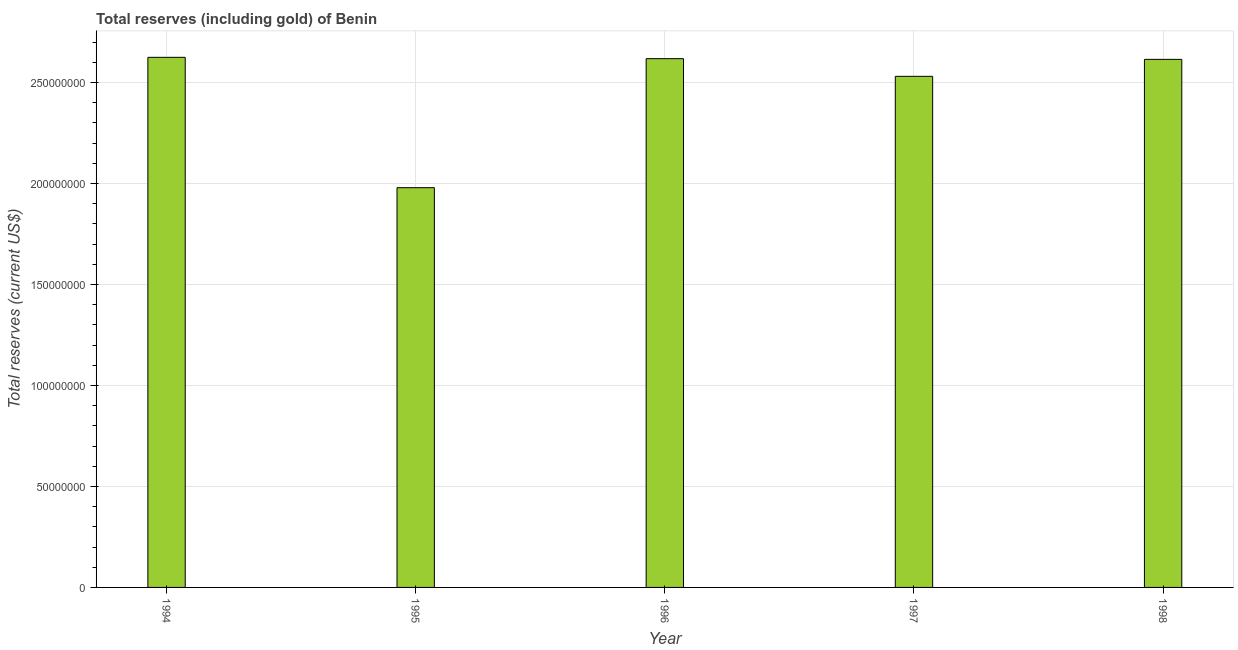What is the title of the graph?
Ensure brevity in your answer.  Total reserves (including gold) of Benin. What is the label or title of the Y-axis?
Offer a terse response. Total reserves (current US$). What is the total reserves (including gold) in 1996?
Make the answer very short. 2.62e+08. Across all years, what is the maximum total reserves (including gold)?
Offer a terse response. 2.62e+08. Across all years, what is the minimum total reserves (including gold)?
Ensure brevity in your answer.  1.98e+08. In which year was the total reserves (including gold) minimum?
Provide a short and direct response. 1995. What is the sum of the total reserves (including gold)?
Keep it short and to the point. 1.24e+09. What is the difference between the total reserves (including gold) in 1994 and 1996?
Make the answer very short. 6.64e+05. What is the average total reserves (including gold) per year?
Your answer should be compact. 2.47e+08. What is the median total reserves (including gold)?
Make the answer very short. 2.61e+08. In how many years, is the total reserves (including gold) greater than 40000000 US$?
Make the answer very short. 5. What is the ratio of the total reserves (including gold) in 1994 to that in 1996?
Your response must be concise. 1. What is the difference between the highest and the second highest total reserves (including gold)?
Offer a very short reply. 6.64e+05. What is the difference between the highest and the lowest total reserves (including gold)?
Your response must be concise. 6.45e+07. In how many years, is the total reserves (including gold) greater than the average total reserves (including gold) taken over all years?
Your answer should be very brief. 4. How many bars are there?
Your answer should be compact. 5. Are all the bars in the graph horizontal?
Offer a very short reply. No. What is the difference between two consecutive major ticks on the Y-axis?
Keep it short and to the point. 5.00e+07. Are the values on the major ticks of Y-axis written in scientific E-notation?
Offer a very short reply. No. What is the Total reserves (current US$) in 1994?
Give a very brief answer. 2.62e+08. What is the Total reserves (current US$) of 1995?
Offer a very short reply. 1.98e+08. What is the Total reserves (current US$) in 1996?
Give a very brief answer. 2.62e+08. What is the Total reserves (current US$) in 1997?
Keep it short and to the point. 2.53e+08. What is the Total reserves (current US$) of 1998?
Give a very brief answer. 2.61e+08. What is the difference between the Total reserves (current US$) in 1994 and 1995?
Provide a succinct answer. 6.45e+07. What is the difference between the Total reserves (current US$) in 1994 and 1996?
Make the answer very short. 6.64e+05. What is the difference between the Total reserves (current US$) in 1994 and 1997?
Offer a terse response. 9.42e+06. What is the difference between the Total reserves (current US$) in 1994 and 1998?
Keep it short and to the point. 1.01e+06. What is the difference between the Total reserves (current US$) in 1995 and 1996?
Keep it short and to the point. -6.39e+07. What is the difference between the Total reserves (current US$) in 1995 and 1997?
Offer a very short reply. -5.51e+07. What is the difference between the Total reserves (current US$) in 1995 and 1998?
Offer a terse response. -6.35e+07. What is the difference between the Total reserves (current US$) in 1996 and 1997?
Your answer should be compact. 8.75e+06. What is the difference between the Total reserves (current US$) in 1996 and 1998?
Your answer should be very brief. 3.42e+05. What is the difference between the Total reserves (current US$) in 1997 and 1998?
Your answer should be very brief. -8.41e+06. What is the ratio of the Total reserves (current US$) in 1994 to that in 1995?
Your answer should be compact. 1.33. What is the ratio of the Total reserves (current US$) in 1994 to that in 1997?
Provide a short and direct response. 1.04. What is the ratio of the Total reserves (current US$) in 1994 to that in 1998?
Keep it short and to the point. 1. What is the ratio of the Total reserves (current US$) in 1995 to that in 1996?
Make the answer very short. 0.76. What is the ratio of the Total reserves (current US$) in 1995 to that in 1997?
Provide a short and direct response. 0.78. What is the ratio of the Total reserves (current US$) in 1995 to that in 1998?
Your answer should be compact. 0.76. What is the ratio of the Total reserves (current US$) in 1996 to that in 1997?
Offer a terse response. 1.03. What is the ratio of the Total reserves (current US$) in 1996 to that in 1998?
Your answer should be very brief. 1. 